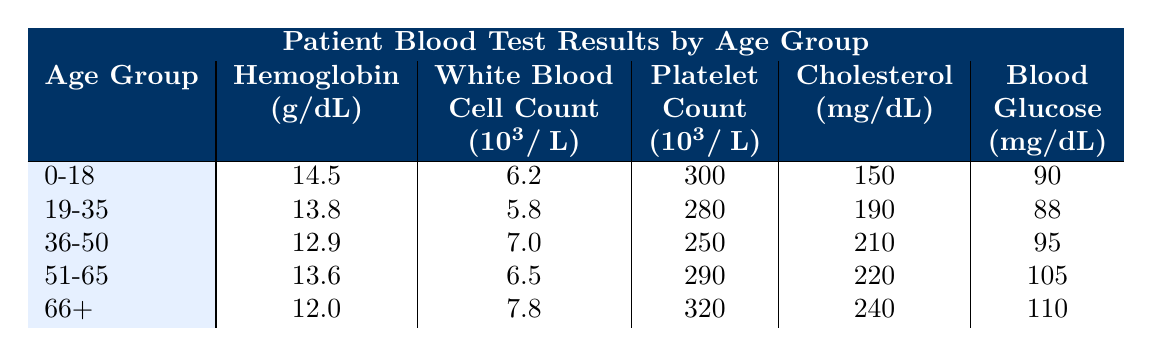What is the Hemoglobin level for the age group 36-50? The table lists the Hemoglobin levels for various age groups. For the age group 36-50, the Hemoglobin level is 12.9 g/dL.
Answer: 12.9 g/dL Which age group has the highest White Blood Cell Count? Looking at the White Blood Cell Count values in the table, the highest is 7.8 from the age group 66+.
Answer: 66+ What is the difference in Cholesterol levels between the age groups 0-18 and 51-65? The Cholesterol level for 0-18 is 150 mg/dL and for 51-65 it is 220 mg/dL. To find the difference, subtract: 220 - 150 = 70.
Answer: 70 mg/dL Is the Platelet Count for the age group 19-35 greater than that for age group 36-50? The Platelet Count for 19-35 is 280 and for 36-50 it is 250. Since 280 is greater than 250, the statement is true.
Answer: Yes What is the average Blood Glucose level across all age groups? To find the average Blood Glucose, add all levels together: 90 + 88 + 95 + 105 + 110 = 488. Then divide by 5 (the number of age groups): 488 / 5 = 97.6.
Answer: 97.6 mg/dL Which age group has the highest Cholesterol level? The Cholesterol levels in the table are 150, 190, 210, 220, and 240. The highest value is 240 from the age group 66+.
Answer: 66+ Is the Hemoglobin level for age group 51-65 lower than that for age group 19-35? The Hemoglobin level for 51-65 is 13.6 and for 19-35 it is 13.8. Since 13.6 is lower than 13.8, the answer is true.
Answer: Yes What is the total White Blood Cell Count for the age group 0-18 and 36-50 combined? The White Blood Cell Count for 0-18 is 6.2 and for 36-50 it is 7.0. Adding these values together gives 6.2 + 7.0 = 13.2.
Answer: 13.2 (10^3/μL) What is the difference in Hemoglobin levels between the oldest and youngest age groups? The Hemoglobin level for the 0-18 age group is 14.5 g/dL and for 66+ it is 12.0 g/dL. The difference is 14.5 - 12.0 = 2.5 g/dL.
Answer: 2.5 g/dL 